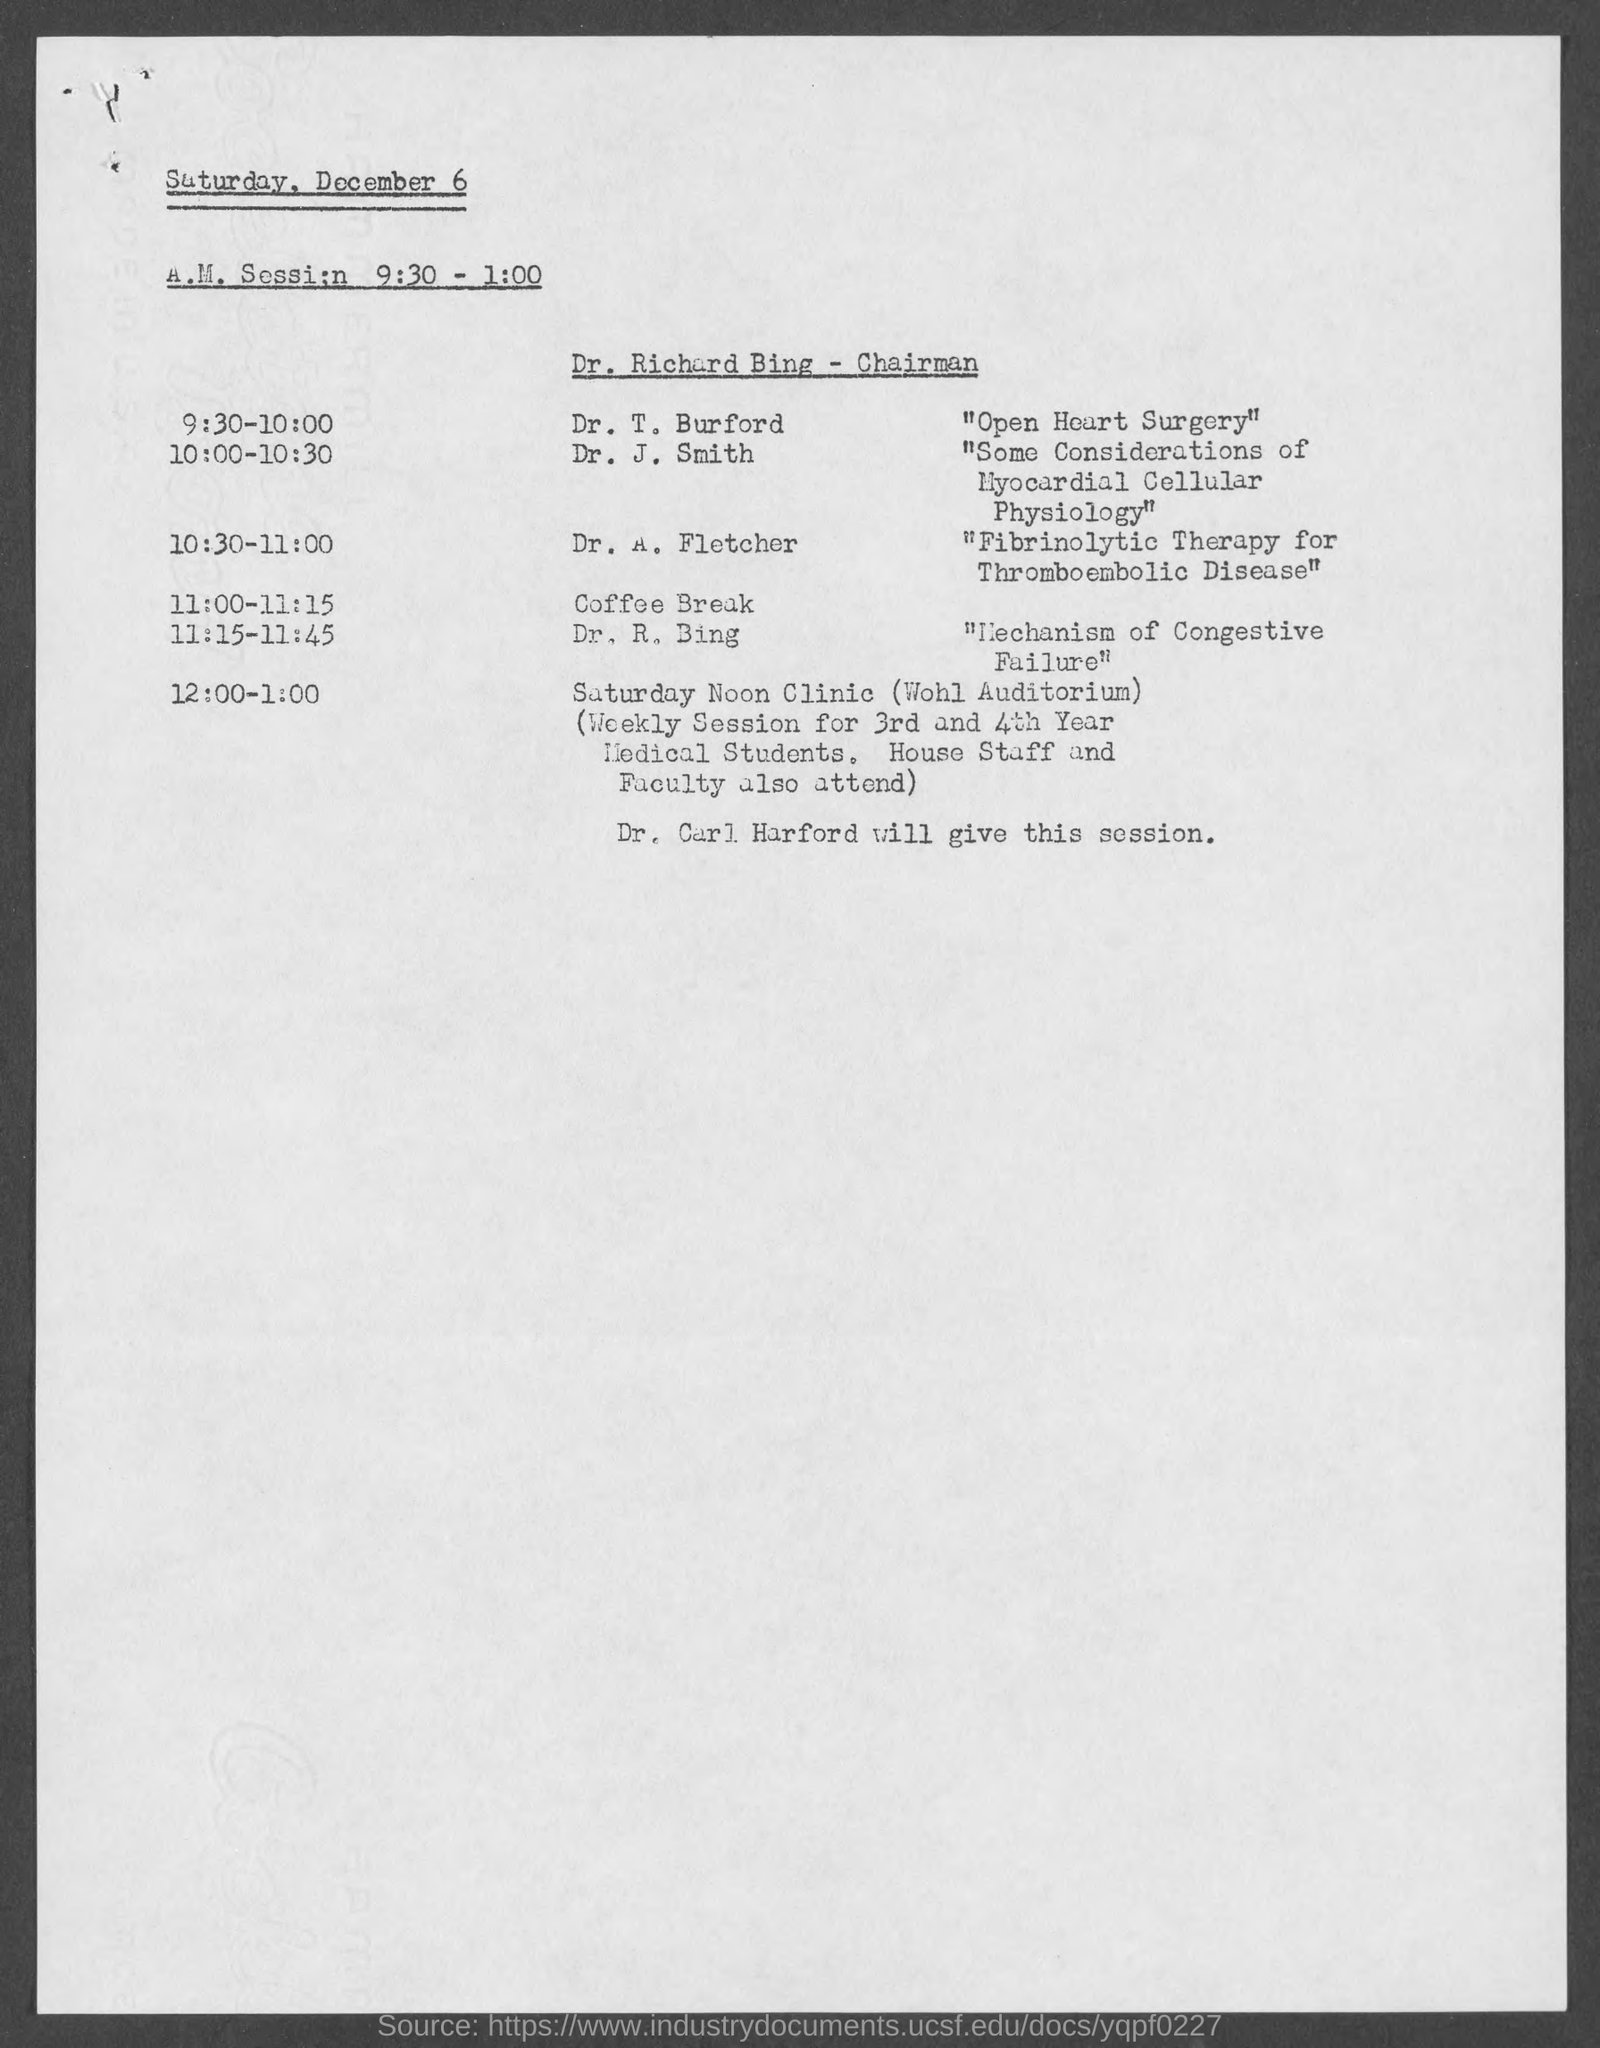When is the A.M. session on Saturday, December 6?
Your answer should be very brief. 9:30 - 1:00. Who is the chairman for A.M. Session?
Make the answer very short. Dr. Richard Bing. What is the topic from 11:15 - 11:45?
Your answer should be very brief. "mechanism of congestive failure". Who will give the session from 12:00 - 1:00?
Offer a terse response. Dr. carl Harford. Who will give the session on "Fibrinolytic Therapy for Thromboembolic Disease?
Provide a succinct answer. Dr. A. Fletcher. What is Dr. T. Burford's session about?
Give a very brief answer. "Open Heart Surgery". What is the topic for the session from 10:00 -10:30?
Make the answer very short. "some considerations of myocardial cellular physiology". Where is the Saturday Noon Clinic going to be held?
Keep it short and to the point. WOHL auditorium. 